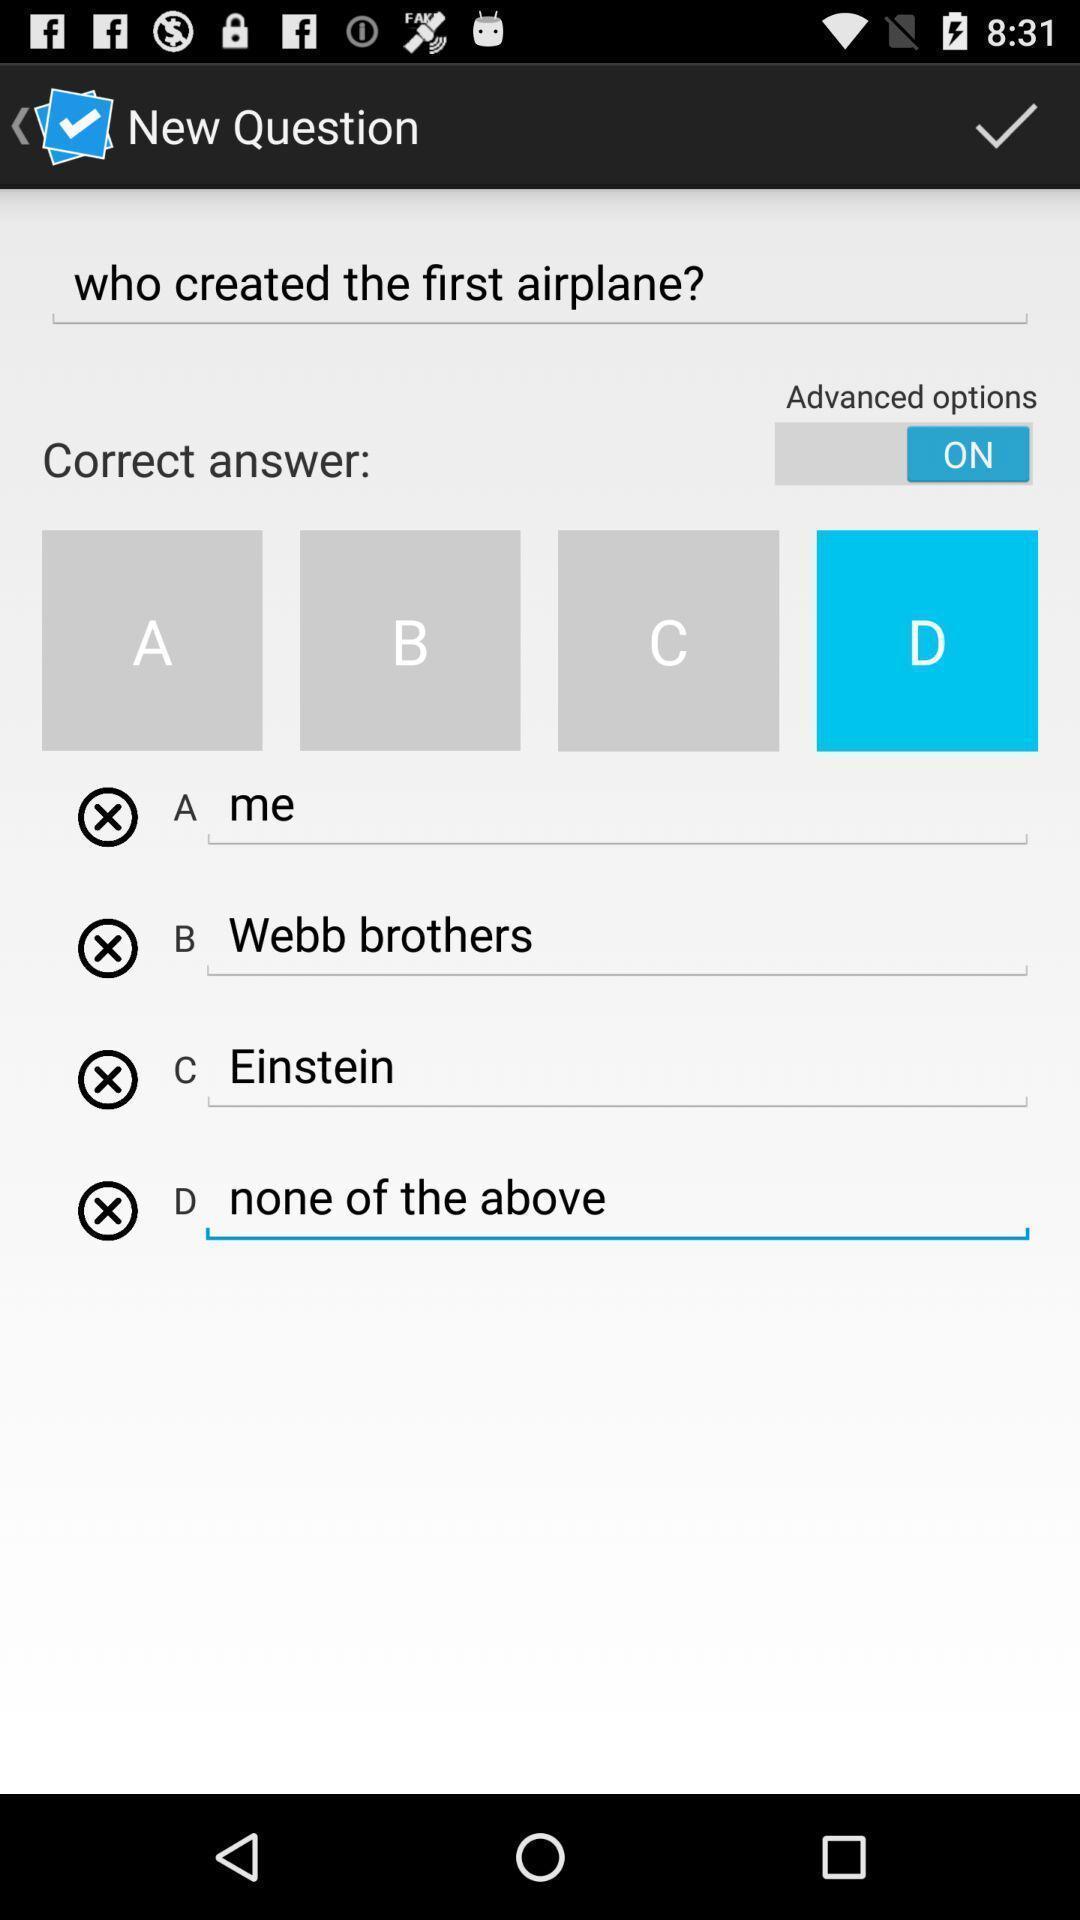What details can you identify in this image? Search bar to search for the questions. 